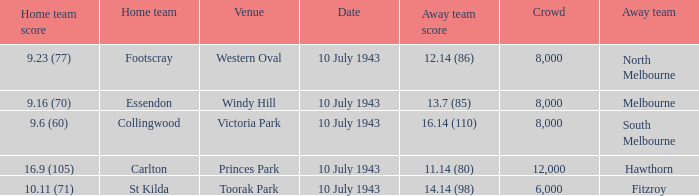When the Away team scored 14.14 (98), which Venue did the game take place? Toorak Park. 